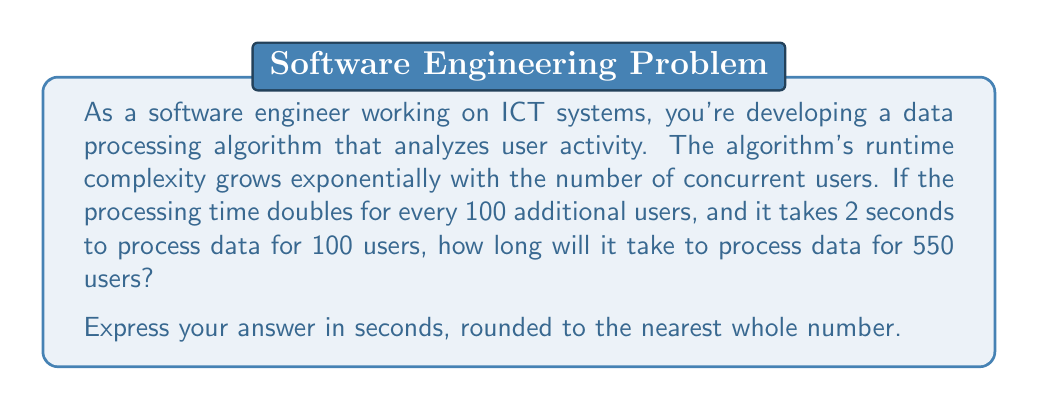Can you solve this math problem? Let's approach this step-by-step:

1) First, we need to identify the exponential growth function. In this case, it's of the form:

   $$ T = a \cdot 2^{n/100} $$

   Where $T$ is the processing time, $a$ is the initial processing time, and $n$ is the number of users.

2) We're given that $a = 2$ seconds (for 100 users), so our function becomes:

   $$ T = 2 \cdot 2^{n/100} $$

3) We want to find $T$ when $n = 550$. Let's substitute this:

   $$ T = 2 \cdot 2^{550/100} $$

4) Simplify the exponent:

   $$ T = 2 \cdot 2^{5.5} $$

5) We can break this down:

   $$ T = 2 \cdot 2^5 \cdot 2^{0.5} $$

6) Calculate:
   
   $$ T = 2 \cdot 32 \cdot \sqrt{2} $$
   $$ T = 64 \cdot \sqrt{2} $$
   $$ T \approx 64 \cdot 1.4142 $$
   $$ T \approx 90.5088 $$

7) Rounding to the nearest whole number:

   $$ T \approx 91 $$

Therefore, it will take approximately 91 seconds to process data for 550 users.
Answer: 91 seconds 